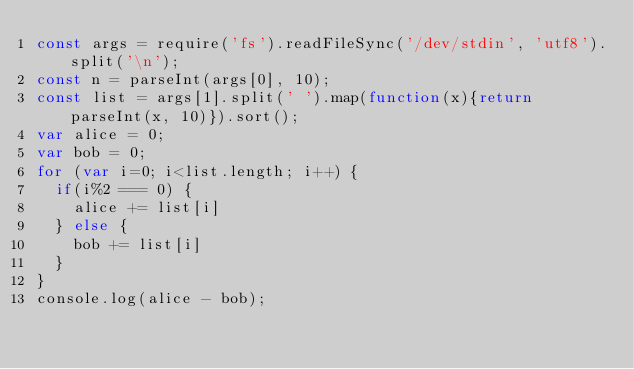<code> <loc_0><loc_0><loc_500><loc_500><_JavaScript_>const args = require('fs').readFileSync('/dev/stdin', 'utf8').split('\n');
const n = parseInt(args[0], 10);
const list = args[1].split(' ').map(function(x){return parseInt(x, 10)}).sort();
var alice = 0;
var bob = 0;
for (var i=0; i<list.length; i++) {
  if(i%2 === 0) {
    alice += list[i]
  } else {
    bob += list[i]
  }
}
console.log(alice - bob);</code> 